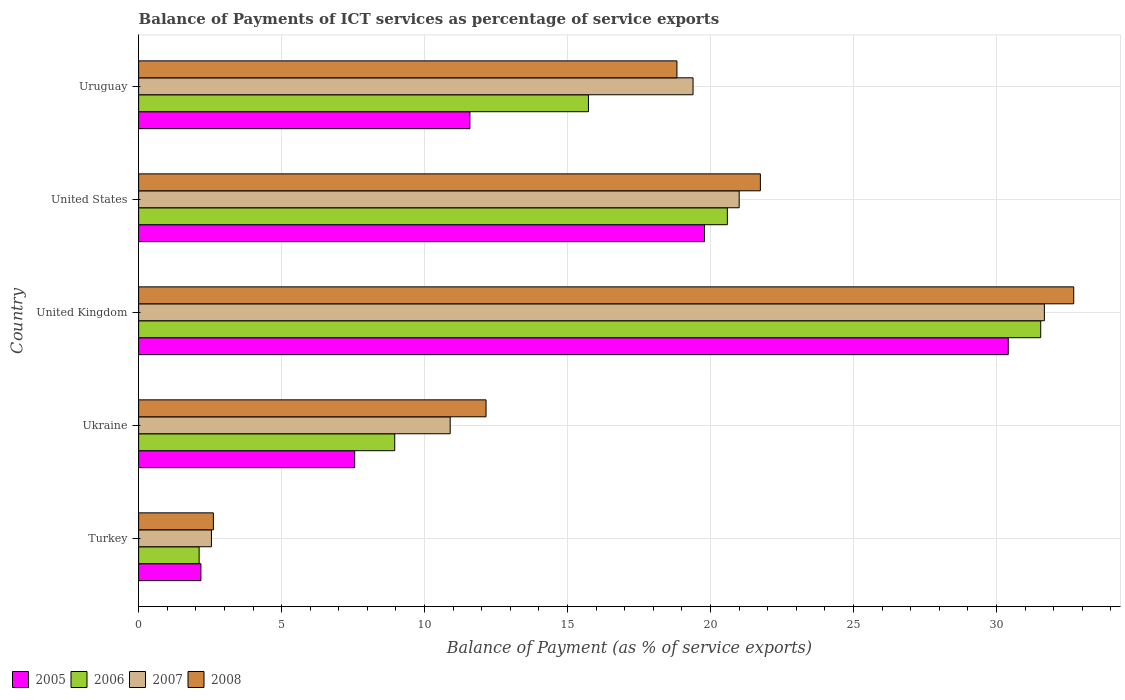Are the number of bars per tick equal to the number of legend labels?
Your answer should be very brief. Yes. Are the number of bars on each tick of the Y-axis equal?
Ensure brevity in your answer.  Yes. How many bars are there on the 4th tick from the bottom?
Give a very brief answer. 4. What is the label of the 1st group of bars from the top?
Provide a succinct answer. Uruguay. In how many cases, is the number of bars for a given country not equal to the number of legend labels?
Offer a very short reply. 0. What is the balance of payments of ICT services in 2006 in Uruguay?
Give a very brief answer. 15.73. Across all countries, what is the maximum balance of payments of ICT services in 2007?
Your answer should be very brief. 31.68. Across all countries, what is the minimum balance of payments of ICT services in 2008?
Offer a terse response. 2.61. In which country was the balance of payments of ICT services in 2008 maximum?
Your answer should be very brief. United Kingdom. What is the total balance of payments of ICT services in 2008 in the graph?
Keep it short and to the point. 88.04. What is the difference between the balance of payments of ICT services in 2008 in United States and that in Uruguay?
Your answer should be very brief. 2.92. What is the difference between the balance of payments of ICT services in 2008 in Ukraine and the balance of payments of ICT services in 2005 in Uruguay?
Provide a succinct answer. 0.56. What is the average balance of payments of ICT services in 2005 per country?
Offer a very short reply. 14.3. What is the difference between the balance of payments of ICT services in 2007 and balance of payments of ICT services in 2005 in United States?
Your answer should be compact. 1.21. What is the ratio of the balance of payments of ICT services in 2007 in Turkey to that in United Kingdom?
Ensure brevity in your answer.  0.08. Is the difference between the balance of payments of ICT services in 2007 in Turkey and Ukraine greater than the difference between the balance of payments of ICT services in 2005 in Turkey and Ukraine?
Keep it short and to the point. No. What is the difference between the highest and the second highest balance of payments of ICT services in 2007?
Offer a very short reply. 10.67. What is the difference between the highest and the lowest balance of payments of ICT services in 2008?
Provide a short and direct response. 30.09. In how many countries, is the balance of payments of ICT services in 2007 greater than the average balance of payments of ICT services in 2007 taken over all countries?
Provide a succinct answer. 3. Is the sum of the balance of payments of ICT services in 2007 in United Kingdom and Uruguay greater than the maximum balance of payments of ICT services in 2008 across all countries?
Provide a short and direct response. Yes. What does the 4th bar from the top in United Kingdom represents?
Keep it short and to the point. 2005. What does the 4th bar from the bottom in Uruguay represents?
Your response must be concise. 2008. Are all the bars in the graph horizontal?
Offer a very short reply. Yes. What is the difference between two consecutive major ticks on the X-axis?
Your response must be concise. 5. Are the values on the major ticks of X-axis written in scientific E-notation?
Ensure brevity in your answer.  No. What is the title of the graph?
Give a very brief answer. Balance of Payments of ICT services as percentage of service exports. Does "1978" appear as one of the legend labels in the graph?
Your answer should be very brief. No. What is the label or title of the X-axis?
Offer a terse response. Balance of Payment (as % of service exports). What is the Balance of Payment (as % of service exports) in 2005 in Turkey?
Provide a short and direct response. 2.18. What is the Balance of Payment (as % of service exports) of 2006 in Turkey?
Offer a terse response. 2.12. What is the Balance of Payment (as % of service exports) of 2007 in Turkey?
Offer a very short reply. 2.55. What is the Balance of Payment (as % of service exports) of 2008 in Turkey?
Offer a very short reply. 2.61. What is the Balance of Payment (as % of service exports) in 2005 in Ukraine?
Ensure brevity in your answer.  7.56. What is the Balance of Payment (as % of service exports) in 2006 in Ukraine?
Provide a short and direct response. 8.96. What is the Balance of Payment (as % of service exports) of 2007 in Ukraine?
Make the answer very short. 10.9. What is the Balance of Payment (as % of service exports) in 2008 in Ukraine?
Your answer should be compact. 12.15. What is the Balance of Payment (as % of service exports) in 2005 in United Kingdom?
Keep it short and to the point. 30.41. What is the Balance of Payment (as % of service exports) of 2006 in United Kingdom?
Give a very brief answer. 31.55. What is the Balance of Payment (as % of service exports) in 2007 in United Kingdom?
Provide a succinct answer. 31.68. What is the Balance of Payment (as % of service exports) of 2008 in United Kingdom?
Ensure brevity in your answer.  32.7. What is the Balance of Payment (as % of service exports) in 2005 in United States?
Ensure brevity in your answer.  19.79. What is the Balance of Payment (as % of service exports) of 2006 in United States?
Your answer should be very brief. 20.59. What is the Balance of Payment (as % of service exports) in 2007 in United States?
Make the answer very short. 21. What is the Balance of Payment (as % of service exports) of 2008 in United States?
Offer a terse response. 21.74. What is the Balance of Payment (as % of service exports) of 2005 in Uruguay?
Make the answer very short. 11.59. What is the Balance of Payment (as % of service exports) of 2006 in Uruguay?
Give a very brief answer. 15.73. What is the Balance of Payment (as % of service exports) in 2007 in Uruguay?
Your answer should be very brief. 19.39. What is the Balance of Payment (as % of service exports) of 2008 in Uruguay?
Keep it short and to the point. 18.83. Across all countries, what is the maximum Balance of Payment (as % of service exports) in 2005?
Provide a short and direct response. 30.41. Across all countries, what is the maximum Balance of Payment (as % of service exports) in 2006?
Make the answer very short. 31.55. Across all countries, what is the maximum Balance of Payment (as % of service exports) of 2007?
Make the answer very short. 31.68. Across all countries, what is the maximum Balance of Payment (as % of service exports) in 2008?
Make the answer very short. 32.7. Across all countries, what is the minimum Balance of Payment (as % of service exports) of 2005?
Your answer should be compact. 2.18. Across all countries, what is the minimum Balance of Payment (as % of service exports) in 2006?
Offer a very short reply. 2.12. Across all countries, what is the minimum Balance of Payment (as % of service exports) in 2007?
Your answer should be very brief. 2.55. Across all countries, what is the minimum Balance of Payment (as % of service exports) in 2008?
Make the answer very short. 2.61. What is the total Balance of Payment (as % of service exports) in 2005 in the graph?
Offer a terse response. 71.52. What is the total Balance of Payment (as % of service exports) in 2006 in the graph?
Ensure brevity in your answer.  78.94. What is the total Balance of Payment (as % of service exports) of 2007 in the graph?
Your answer should be compact. 85.51. What is the total Balance of Payment (as % of service exports) in 2008 in the graph?
Keep it short and to the point. 88.04. What is the difference between the Balance of Payment (as % of service exports) in 2005 in Turkey and that in Ukraine?
Make the answer very short. -5.38. What is the difference between the Balance of Payment (as % of service exports) in 2006 in Turkey and that in Ukraine?
Keep it short and to the point. -6.84. What is the difference between the Balance of Payment (as % of service exports) of 2007 in Turkey and that in Ukraine?
Your answer should be compact. -8.35. What is the difference between the Balance of Payment (as % of service exports) in 2008 in Turkey and that in Ukraine?
Provide a succinct answer. -9.54. What is the difference between the Balance of Payment (as % of service exports) of 2005 in Turkey and that in United Kingdom?
Give a very brief answer. -28.23. What is the difference between the Balance of Payment (as % of service exports) of 2006 in Turkey and that in United Kingdom?
Offer a terse response. -29.43. What is the difference between the Balance of Payment (as % of service exports) in 2007 in Turkey and that in United Kingdom?
Your response must be concise. -29.13. What is the difference between the Balance of Payment (as % of service exports) of 2008 in Turkey and that in United Kingdom?
Provide a short and direct response. -30.09. What is the difference between the Balance of Payment (as % of service exports) in 2005 in Turkey and that in United States?
Your response must be concise. -17.61. What is the difference between the Balance of Payment (as % of service exports) of 2006 in Turkey and that in United States?
Ensure brevity in your answer.  -18.47. What is the difference between the Balance of Payment (as % of service exports) in 2007 in Turkey and that in United States?
Keep it short and to the point. -18.46. What is the difference between the Balance of Payment (as % of service exports) of 2008 in Turkey and that in United States?
Provide a succinct answer. -19.13. What is the difference between the Balance of Payment (as % of service exports) in 2005 in Turkey and that in Uruguay?
Keep it short and to the point. -9.41. What is the difference between the Balance of Payment (as % of service exports) in 2006 in Turkey and that in Uruguay?
Provide a short and direct response. -13.62. What is the difference between the Balance of Payment (as % of service exports) of 2007 in Turkey and that in Uruguay?
Give a very brief answer. -16.84. What is the difference between the Balance of Payment (as % of service exports) of 2008 in Turkey and that in Uruguay?
Make the answer very short. -16.21. What is the difference between the Balance of Payment (as % of service exports) of 2005 in Ukraine and that in United Kingdom?
Provide a short and direct response. -22.86. What is the difference between the Balance of Payment (as % of service exports) of 2006 in Ukraine and that in United Kingdom?
Your answer should be very brief. -22.59. What is the difference between the Balance of Payment (as % of service exports) in 2007 in Ukraine and that in United Kingdom?
Your answer should be compact. -20.78. What is the difference between the Balance of Payment (as % of service exports) in 2008 in Ukraine and that in United Kingdom?
Provide a succinct answer. -20.55. What is the difference between the Balance of Payment (as % of service exports) of 2005 in Ukraine and that in United States?
Provide a short and direct response. -12.23. What is the difference between the Balance of Payment (as % of service exports) of 2006 in Ukraine and that in United States?
Offer a very short reply. -11.63. What is the difference between the Balance of Payment (as % of service exports) in 2007 in Ukraine and that in United States?
Give a very brief answer. -10.11. What is the difference between the Balance of Payment (as % of service exports) in 2008 in Ukraine and that in United States?
Give a very brief answer. -9.59. What is the difference between the Balance of Payment (as % of service exports) in 2005 in Ukraine and that in Uruguay?
Provide a short and direct response. -4.03. What is the difference between the Balance of Payment (as % of service exports) in 2006 in Ukraine and that in Uruguay?
Offer a very short reply. -6.77. What is the difference between the Balance of Payment (as % of service exports) in 2007 in Ukraine and that in Uruguay?
Your answer should be compact. -8.49. What is the difference between the Balance of Payment (as % of service exports) in 2008 in Ukraine and that in Uruguay?
Your answer should be compact. -6.68. What is the difference between the Balance of Payment (as % of service exports) of 2005 in United Kingdom and that in United States?
Keep it short and to the point. 10.62. What is the difference between the Balance of Payment (as % of service exports) of 2006 in United Kingdom and that in United States?
Offer a very short reply. 10.96. What is the difference between the Balance of Payment (as % of service exports) of 2007 in United Kingdom and that in United States?
Provide a short and direct response. 10.67. What is the difference between the Balance of Payment (as % of service exports) of 2008 in United Kingdom and that in United States?
Provide a short and direct response. 10.96. What is the difference between the Balance of Payment (as % of service exports) of 2005 in United Kingdom and that in Uruguay?
Your answer should be compact. 18.83. What is the difference between the Balance of Payment (as % of service exports) of 2006 in United Kingdom and that in Uruguay?
Make the answer very short. 15.82. What is the difference between the Balance of Payment (as % of service exports) of 2007 in United Kingdom and that in Uruguay?
Make the answer very short. 12.29. What is the difference between the Balance of Payment (as % of service exports) in 2008 in United Kingdom and that in Uruguay?
Offer a terse response. 13.88. What is the difference between the Balance of Payment (as % of service exports) in 2005 in United States and that in Uruguay?
Ensure brevity in your answer.  8.2. What is the difference between the Balance of Payment (as % of service exports) in 2006 in United States and that in Uruguay?
Offer a very short reply. 4.86. What is the difference between the Balance of Payment (as % of service exports) of 2007 in United States and that in Uruguay?
Ensure brevity in your answer.  1.61. What is the difference between the Balance of Payment (as % of service exports) of 2008 in United States and that in Uruguay?
Your response must be concise. 2.92. What is the difference between the Balance of Payment (as % of service exports) in 2005 in Turkey and the Balance of Payment (as % of service exports) in 2006 in Ukraine?
Make the answer very short. -6.78. What is the difference between the Balance of Payment (as % of service exports) of 2005 in Turkey and the Balance of Payment (as % of service exports) of 2007 in Ukraine?
Make the answer very short. -8.72. What is the difference between the Balance of Payment (as % of service exports) of 2005 in Turkey and the Balance of Payment (as % of service exports) of 2008 in Ukraine?
Make the answer very short. -9.97. What is the difference between the Balance of Payment (as % of service exports) in 2006 in Turkey and the Balance of Payment (as % of service exports) in 2007 in Ukraine?
Ensure brevity in your answer.  -8.78. What is the difference between the Balance of Payment (as % of service exports) of 2006 in Turkey and the Balance of Payment (as % of service exports) of 2008 in Ukraine?
Provide a succinct answer. -10.03. What is the difference between the Balance of Payment (as % of service exports) in 2007 in Turkey and the Balance of Payment (as % of service exports) in 2008 in Ukraine?
Ensure brevity in your answer.  -9.6. What is the difference between the Balance of Payment (as % of service exports) in 2005 in Turkey and the Balance of Payment (as % of service exports) in 2006 in United Kingdom?
Ensure brevity in your answer.  -29.37. What is the difference between the Balance of Payment (as % of service exports) in 2005 in Turkey and the Balance of Payment (as % of service exports) in 2007 in United Kingdom?
Your response must be concise. -29.5. What is the difference between the Balance of Payment (as % of service exports) in 2005 in Turkey and the Balance of Payment (as % of service exports) in 2008 in United Kingdom?
Give a very brief answer. -30.52. What is the difference between the Balance of Payment (as % of service exports) in 2006 in Turkey and the Balance of Payment (as % of service exports) in 2007 in United Kingdom?
Your response must be concise. -29.56. What is the difference between the Balance of Payment (as % of service exports) of 2006 in Turkey and the Balance of Payment (as % of service exports) of 2008 in United Kingdom?
Your answer should be compact. -30.59. What is the difference between the Balance of Payment (as % of service exports) in 2007 in Turkey and the Balance of Payment (as % of service exports) in 2008 in United Kingdom?
Ensure brevity in your answer.  -30.16. What is the difference between the Balance of Payment (as % of service exports) in 2005 in Turkey and the Balance of Payment (as % of service exports) in 2006 in United States?
Your response must be concise. -18.41. What is the difference between the Balance of Payment (as % of service exports) of 2005 in Turkey and the Balance of Payment (as % of service exports) of 2007 in United States?
Ensure brevity in your answer.  -18.82. What is the difference between the Balance of Payment (as % of service exports) of 2005 in Turkey and the Balance of Payment (as % of service exports) of 2008 in United States?
Provide a succinct answer. -19.57. What is the difference between the Balance of Payment (as % of service exports) in 2006 in Turkey and the Balance of Payment (as % of service exports) in 2007 in United States?
Offer a terse response. -18.89. What is the difference between the Balance of Payment (as % of service exports) in 2006 in Turkey and the Balance of Payment (as % of service exports) in 2008 in United States?
Your answer should be very brief. -19.63. What is the difference between the Balance of Payment (as % of service exports) in 2007 in Turkey and the Balance of Payment (as % of service exports) in 2008 in United States?
Make the answer very short. -19.2. What is the difference between the Balance of Payment (as % of service exports) in 2005 in Turkey and the Balance of Payment (as % of service exports) in 2006 in Uruguay?
Your answer should be very brief. -13.55. What is the difference between the Balance of Payment (as % of service exports) of 2005 in Turkey and the Balance of Payment (as % of service exports) of 2007 in Uruguay?
Your response must be concise. -17.21. What is the difference between the Balance of Payment (as % of service exports) in 2005 in Turkey and the Balance of Payment (as % of service exports) in 2008 in Uruguay?
Provide a succinct answer. -16.65. What is the difference between the Balance of Payment (as % of service exports) in 2006 in Turkey and the Balance of Payment (as % of service exports) in 2007 in Uruguay?
Ensure brevity in your answer.  -17.27. What is the difference between the Balance of Payment (as % of service exports) of 2006 in Turkey and the Balance of Payment (as % of service exports) of 2008 in Uruguay?
Provide a succinct answer. -16.71. What is the difference between the Balance of Payment (as % of service exports) of 2007 in Turkey and the Balance of Payment (as % of service exports) of 2008 in Uruguay?
Give a very brief answer. -16.28. What is the difference between the Balance of Payment (as % of service exports) of 2005 in Ukraine and the Balance of Payment (as % of service exports) of 2006 in United Kingdom?
Your answer should be compact. -23.99. What is the difference between the Balance of Payment (as % of service exports) in 2005 in Ukraine and the Balance of Payment (as % of service exports) in 2007 in United Kingdom?
Offer a very short reply. -24.12. What is the difference between the Balance of Payment (as % of service exports) of 2005 in Ukraine and the Balance of Payment (as % of service exports) of 2008 in United Kingdom?
Your response must be concise. -25.15. What is the difference between the Balance of Payment (as % of service exports) of 2006 in Ukraine and the Balance of Payment (as % of service exports) of 2007 in United Kingdom?
Offer a very short reply. -22.72. What is the difference between the Balance of Payment (as % of service exports) in 2006 in Ukraine and the Balance of Payment (as % of service exports) in 2008 in United Kingdom?
Ensure brevity in your answer.  -23.75. What is the difference between the Balance of Payment (as % of service exports) in 2007 in Ukraine and the Balance of Payment (as % of service exports) in 2008 in United Kingdom?
Make the answer very short. -21.81. What is the difference between the Balance of Payment (as % of service exports) of 2005 in Ukraine and the Balance of Payment (as % of service exports) of 2006 in United States?
Offer a very short reply. -13.03. What is the difference between the Balance of Payment (as % of service exports) in 2005 in Ukraine and the Balance of Payment (as % of service exports) in 2007 in United States?
Provide a succinct answer. -13.45. What is the difference between the Balance of Payment (as % of service exports) of 2005 in Ukraine and the Balance of Payment (as % of service exports) of 2008 in United States?
Keep it short and to the point. -14.19. What is the difference between the Balance of Payment (as % of service exports) in 2006 in Ukraine and the Balance of Payment (as % of service exports) in 2007 in United States?
Your answer should be very brief. -12.05. What is the difference between the Balance of Payment (as % of service exports) in 2006 in Ukraine and the Balance of Payment (as % of service exports) in 2008 in United States?
Offer a terse response. -12.79. What is the difference between the Balance of Payment (as % of service exports) in 2007 in Ukraine and the Balance of Payment (as % of service exports) in 2008 in United States?
Your answer should be very brief. -10.85. What is the difference between the Balance of Payment (as % of service exports) in 2005 in Ukraine and the Balance of Payment (as % of service exports) in 2006 in Uruguay?
Your answer should be very brief. -8.18. What is the difference between the Balance of Payment (as % of service exports) of 2005 in Ukraine and the Balance of Payment (as % of service exports) of 2007 in Uruguay?
Provide a succinct answer. -11.83. What is the difference between the Balance of Payment (as % of service exports) in 2005 in Ukraine and the Balance of Payment (as % of service exports) in 2008 in Uruguay?
Your answer should be compact. -11.27. What is the difference between the Balance of Payment (as % of service exports) in 2006 in Ukraine and the Balance of Payment (as % of service exports) in 2007 in Uruguay?
Provide a succinct answer. -10.43. What is the difference between the Balance of Payment (as % of service exports) in 2006 in Ukraine and the Balance of Payment (as % of service exports) in 2008 in Uruguay?
Give a very brief answer. -9.87. What is the difference between the Balance of Payment (as % of service exports) of 2007 in Ukraine and the Balance of Payment (as % of service exports) of 2008 in Uruguay?
Your response must be concise. -7.93. What is the difference between the Balance of Payment (as % of service exports) of 2005 in United Kingdom and the Balance of Payment (as % of service exports) of 2006 in United States?
Your response must be concise. 9.82. What is the difference between the Balance of Payment (as % of service exports) of 2005 in United Kingdom and the Balance of Payment (as % of service exports) of 2007 in United States?
Provide a short and direct response. 9.41. What is the difference between the Balance of Payment (as % of service exports) of 2005 in United Kingdom and the Balance of Payment (as % of service exports) of 2008 in United States?
Keep it short and to the point. 8.67. What is the difference between the Balance of Payment (as % of service exports) of 2006 in United Kingdom and the Balance of Payment (as % of service exports) of 2007 in United States?
Ensure brevity in your answer.  10.55. What is the difference between the Balance of Payment (as % of service exports) in 2006 in United Kingdom and the Balance of Payment (as % of service exports) in 2008 in United States?
Offer a very short reply. 9.8. What is the difference between the Balance of Payment (as % of service exports) in 2007 in United Kingdom and the Balance of Payment (as % of service exports) in 2008 in United States?
Ensure brevity in your answer.  9.93. What is the difference between the Balance of Payment (as % of service exports) of 2005 in United Kingdom and the Balance of Payment (as % of service exports) of 2006 in Uruguay?
Make the answer very short. 14.68. What is the difference between the Balance of Payment (as % of service exports) in 2005 in United Kingdom and the Balance of Payment (as % of service exports) in 2007 in Uruguay?
Your response must be concise. 11.02. What is the difference between the Balance of Payment (as % of service exports) of 2005 in United Kingdom and the Balance of Payment (as % of service exports) of 2008 in Uruguay?
Your answer should be compact. 11.59. What is the difference between the Balance of Payment (as % of service exports) of 2006 in United Kingdom and the Balance of Payment (as % of service exports) of 2007 in Uruguay?
Your answer should be compact. 12.16. What is the difference between the Balance of Payment (as % of service exports) in 2006 in United Kingdom and the Balance of Payment (as % of service exports) in 2008 in Uruguay?
Offer a terse response. 12.72. What is the difference between the Balance of Payment (as % of service exports) of 2007 in United Kingdom and the Balance of Payment (as % of service exports) of 2008 in Uruguay?
Your answer should be very brief. 12.85. What is the difference between the Balance of Payment (as % of service exports) in 2005 in United States and the Balance of Payment (as % of service exports) in 2006 in Uruguay?
Offer a terse response. 4.06. What is the difference between the Balance of Payment (as % of service exports) of 2005 in United States and the Balance of Payment (as % of service exports) of 2007 in Uruguay?
Provide a succinct answer. 0.4. What is the difference between the Balance of Payment (as % of service exports) in 2005 in United States and the Balance of Payment (as % of service exports) in 2008 in Uruguay?
Provide a short and direct response. 0.96. What is the difference between the Balance of Payment (as % of service exports) of 2006 in United States and the Balance of Payment (as % of service exports) of 2007 in Uruguay?
Keep it short and to the point. 1.2. What is the difference between the Balance of Payment (as % of service exports) in 2006 in United States and the Balance of Payment (as % of service exports) in 2008 in Uruguay?
Offer a very short reply. 1.76. What is the difference between the Balance of Payment (as % of service exports) in 2007 in United States and the Balance of Payment (as % of service exports) in 2008 in Uruguay?
Offer a very short reply. 2.18. What is the average Balance of Payment (as % of service exports) of 2005 per country?
Provide a short and direct response. 14.3. What is the average Balance of Payment (as % of service exports) in 2006 per country?
Your answer should be very brief. 15.79. What is the average Balance of Payment (as % of service exports) in 2007 per country?
Your answer should be very brief. 17.1. What is the average Balance of Payment (as % of service exports) in 2008 per country?
Your response must be concise. 17.61. What is the difference between the Balance of Payment (as % of service exports) in 2005 and Balance of Payment (as % of service exports) in 2006 in Turkey?
Keep it short and to the point. 0.06. What is the difference between the Balance of Payment (as % of service exports) in 2005 and Balance of Payment (as % of service exports) in 2007 in Turkey?
Provide a succinct answer. -0.37. What is the difference between the Balance of Payment (as % of service exports) of 2005 and Balance of Payment (as % of service exports) of 2008 in Turkey?
Provide a short and direct response. -0.44. What is the difference between the Balance of Payment (as % of service exports) of 2006 and Balance of Payment (as % of service exports) of 2007 in Turkey?
Provide a succinct answer. -0.43. What is the difference between the Balance of Payment (as % of service exports) of 2006 and Balance of Payment (as % of service exports) of 2008 in Turkey?
Give a very brief answer. -0.5. What is the difference between the Balance of Payment (as % of service exports) of 2007 and Balance of Payment (as % of service exports) of 2008 in Turkey?
Provide a succinct answer. -0.07. What is the difference between the Balance of Payment (as % of service exports) of 2005 and Balance of Payment (as % of service exports) of 2006 in Ukraine?
Your answer should be compact. -1.4. What is the difference between the Balance of Payment (as % of service exports) in 2005 and Balance of Payment (as % of service exports) in 2007 in Ukraine?
Provide a short and direct response. -3.34. What is the difference between the Balance of Payment (as % of service exports) of 2005 and Balance of Payment (as % of service exports) of 2008 in Ukraine?
Offer a very short reply. -4.59. What is the difference between the Balance of Payment (as % of service exports) of 2006 and Balance of Payment (as % of service exports) of 2007 in Ukraine?
Your answer should be compact. -1.94. What is the difference between the Balance of Payment (as % of service exports) in 2006 and Balance of Payment (as % of service exports) in 2008 in Ukraine?
Make the answer very short. -3.19. What is the difference between the Balance of Payment (as % of service exports) in 2007 and Balance of Payment (as % of service exports) in 2008 in Ukraine?
Make the answer very short. -1.25. What is the difference between the Balance of Payment (as % of service exports) of 2005 and Balance of Payment (as % of service exports) of 2006 in United Kingdom?
Offer a terse response. -1.14. What is the difference between the Balance of Payment (as % of service exports) in 2005 and Balance of Payment (as % of service exports) in 2007 in United Kingdom?
Give a very brief answer. -1.26. What is the difference between the Balance of Payment (as % of service exports) of 2005 and Balance of Payment (as % of service exports) of 2008 in United Kingdom?
Ensure brevity in your answer.  -2.29. What is the difference between the Balance of Payment (as % of service exports) of 2006 and Balance of Payment (as % of service exports) of 2007 in United Kingdom?
Your answer should be compact. -0.13. What is the difference between the Balance of Payment (as % of service exports) of 2006 and Balance of Payment (as % of service exports) of 2008 in United Kingdom?
Offer a very short reply. -1.16. What is the difference between the Balance of Payment (as % of service exports) in 2007 and Balance of Payment (as % of service exports) in 2008 in United Kingdom?
Give a very brief answer. -1.03. What is the difference between the Balance of Payment (as % of service exports) in 2005 and Balance of Payment (as % of service exports) in 2006 in United States?
Make the answer very short. -0.8. What is the difference between the Balance of Payment (as % of service exports) in 2005 and Balance of Payment (as % of service exports) in 2007 in United States?
Your response must be concise. -1.21. What is the difference between the Balance of Payment (as % of service exports) of 2005 and Balance of Payment (as % of service exports) of 2008 in United States?
Keep it short and to the point. -1.95. What is the difference between the Balance of Payment (as % of service exports) of 2006 and Balance of Payment (as % of service exports) of 2007 in United States?
Provide a succinct answer. -0.41. What is the difference between the Balance of Payment (as % of service exports) of 2006 and Balance of Payment (as % of service exports) of 2008 in United States?
Provide a short and direct response. -1.15. What is the difference between the Balance of Payment (as % of service exports) in 2007 and Balance of Payment (as % of service exports) in 2008 in United States?
Provide a short and direct response. -0.74. What is the difference between the Balance of Payment (as % of service exports) in 2005 and Balance of Payment (as % of service exports) in 2006 in Uruguay?
Your response must be concise. -4.15. What is the difference between the Balance of Payment (as % of service exports) in 2005 and Balance of Payment (as % of service exports) in 2007 in Uruguay?
Make the answer very short. -7.8. What is the difference between the Balance of Payment (as % of service exports) in 2005 and Balance of Payment (as % of service exports) in 2008 in Uruguay?
Offer a very short reply. -7.24. What is the difference between the Balance of Payment (as % of service exports) of 2006 and Balance of Payment (as % of service exports) of 2007 in Uruguay?
Provide a short and direct response. -3.66. What is the difference between the Balance of Payment (as % of service exports) in 2006 and Balance of Payment (as % of service exports) in 2008 in Uruguay?
Your answer should be very brief. -3.09. What is the difference between the Balance of Payment (as % of service exports) of 2007 and Balance of Payment (as % of service exports) of 2008 in Uruguay?
Your response must be concise. 0.56. What is the ratio of the Balance of Payment (as % of service exports) in 2005 in Turkey to that in Ukraine?
Your response must be concise. 0.29. What is the ratio of the Balance of Payment (as % of service exports) in 2006 in Turkey to that in Ukraine?
Offer a very short reply. 0.24. What is the ratio of the Balance of Payment (as % of service exports) of 2007 in Turkey to that in Ukraine?
Your response must be concise. 0.23. What is the ratio of the Balance of Payment (as % of service exports) of 2008 in Turkey to that in Ukraine?
Offer a very short reply. 0.22. What is the ratio of the Balance of Payment (as % of service exports) of 2005 in Turkey to that in United Kingdom?
Offer a terse response. 0.07. What is the ratio of the Balance of Payment (as % of service exports) in 2006 in Turkey to that in United Kingdom?
Your response must be concise. 0.07. What is the ratio of the Balance of Payment (as % of service exports) of 2007 in Turkey to that in United Kingdom?
Offer a very short reply. 0.08. What is the ratio of the Balance of Payment (as % of service exports) in 2008 in Turkey to that in United Kingdom?
Ensure brevity in your answer.  0.08. What is the ratio of the Balance of Payment (as % of service exports) in 2005 in Turkey to that in United States?
Provide a succinct answer. 0.11. What is the ratio of the Balance of Payment (as % of service exports) of 2006 in Turkey to that in United States?
Give a very brief answer. 0.1. What is the ratio of the Balance of Payment (as % of service exports) of 2007 in Turkey to that in United States?
Offer a terse response. 0.12. What is the ratio of the Balance of Payment (as % of service exports) of 2008 in Turkey to that in United States?
Keep it short and to the point. 0.12. What is the ratio of the Balance of Payment (as % of service exports) of 2005 in Turkey to that in Uruguay?
Offer a very short reply. 0.19. What is the ratio of the Balance of Payment (as % of service exports) of 2006 in Turkey to that in Uruguay?
Keep it short and to the point. 0.13. What is the ratio of the Balance of Payment (as % of service exports) in 2007 in Turkey to that in Uruguay?
Keep it short and to the point. 0.13. What is the ratio of the Balance of Payment (as % of service exports) in 2008 in Turkey to that in Uruguay?
Provide a short and direct response. 0.14. What is the ratio of the Balance of Payment (as % of service exports) of 2005 in Ukraine to that in United Kingdom?
Offer a terse response. 0.25. What is the ratio of the Balance of Payment (as % of service exports) in 2006 in Ukraine to that in United Kingdom?
Your response must be concise. 0.28. What is the ratio of the Balance of Payment (as % of service exports) in 2007 in Ukraine to that in United Kingdom?
Your response must be concise. 0.34. What is the ratio of the Balance of Payment (as % of service exports) of 2008 in Ukraine to that in United Kingdom?
Your response must be concise. 0.37. What is the ratio of the Balance of Payment (as % of service exports) of 2005 in Ukraine to that in United States?
Make the answer very short. 0.38. What is the ratio of the Balance of Payment (as % of service exports) in 2006 in Ukraine to that in United States?
Give a very brief answer. 0.43. What is the ratio of the Balance of Payment (as % of service exports) of 2007 in Ukraine to that in United States?
Ensure brevity in your answer.  0.52. What is the ratio of the Balance of Payment (as % of service exports) of 2008 in Ukraine to that in United States?
Provide a short and direct response. 0.56. What is the ratio of the Balance of Payment (as % of service exports) in 2005 in Ukraine to that in Uruguay?
Make the answer very short. 0.65. What is the ratio of the Balance of Payment (as % of service exports) in 2006 in Ukraine to that in Uruguay?
Provide a short and direct response. 0.57. What is the ratio of the Balance of Payment (as % of service exports) of 2007 in Ukraine to that in Uruguay?
Provide a succinct answer. 0.56. What is the ratio of the Balance of Payment (as % of service exports) of 2008 in Ukraine to that in Uruguay?
Keep it short and to the point. 0.65. What is the ratio of the Balance of Payment (as % of service exports) in 2005 in United Kingdom to that in United States?
Your response must be concise. 1.54. What is the ratio of the Balance of Payment (as % of service exports) of 2006 in United Kingdom to that in United States?
Ensure brevity in your answer.  1.53. What is the ratio of the Balance of Payment (as % of service exports) in 2007 in United Kingdom to that in United States?
Your answer should be very brief. 1.51. What is the ratio of the Balance of Payment (as % of service exports) in 2008 in United Kingdom to that in United States?
Give a very brief answer. 1.5. What is the ratio of the Balance of Payment (as % of service exports) of 2005 in United Kingdom to that in Uruguay?
Your answer should be very brief. 2.62. What is the ratio of the Balance of Payment (as % of service exports) in 2006 in United Kingdom to that in Uruguay?
Your answer should be compact. 2.01. What is the ratio of the Balance of Payment (as % of service exports) of 2007 in United Kingdom to that in Uruguay?
Offer a very short reply. 1.63. What is the ratio of the Balance of Payment (as % of service exports) of 2008 in United Kingdom to that in Uruguay?
Provide a succinct answer. 1.74. What is the ratio of the Balance of Payment (as % of service exports) in 2005 in United States to that in Uruguay?
Provide a succinct answer. 1.71. What is the ratio of the Balance of Payment (as % of service exports) in 2006 in United States to that in Uruguay?
Offer a terse response. 1.31. What is the ratio of the Balance of Payment (as % of service exports) in 2007 in United States to that in Uruguay?
Your response must be concise. 1.08. What is the ratio of the Balance of Payment (as % of service exports) in 2008 in United States to that in Uruguay?
Make the answer very short. 1.16. What is the difference between the highest and the second highest Balance of Payment (as % of service exports) in 2005?
Give a very brief answer. 10.62. What is the difference between the highest and the second highest Balance of Payment (as % of service exports) of 2006?
Provide a succinct answer. 10.96. What is the difference between the highest and the second highest Balance of Payment (as % of service exports) in 2007?
Offer a terse response. 10.67. What is the difference between the highest and the second highest Balance of Payment (as % of service exports) in 2008?
Your answer should be very brief. 10.96. What is the difference between the highest and the lowest Balance of Payment (as % of service exports) in 2005?
Keep it short and to the point. 28.23. What is the difference between the highest and the lowest Balance of Payment (as % of service exports) in 2006?
Keep it short and to the point. 29.43. What is the difference between the highest and the lowest Balance of Payment (as % of service exports) in 2007?
Ensure brevity in your answer.  29.13. What is the difference between the highest and the lowest Balance of Payment (as % of service exports) in 2008?
Make the answer very short. 30.09. 